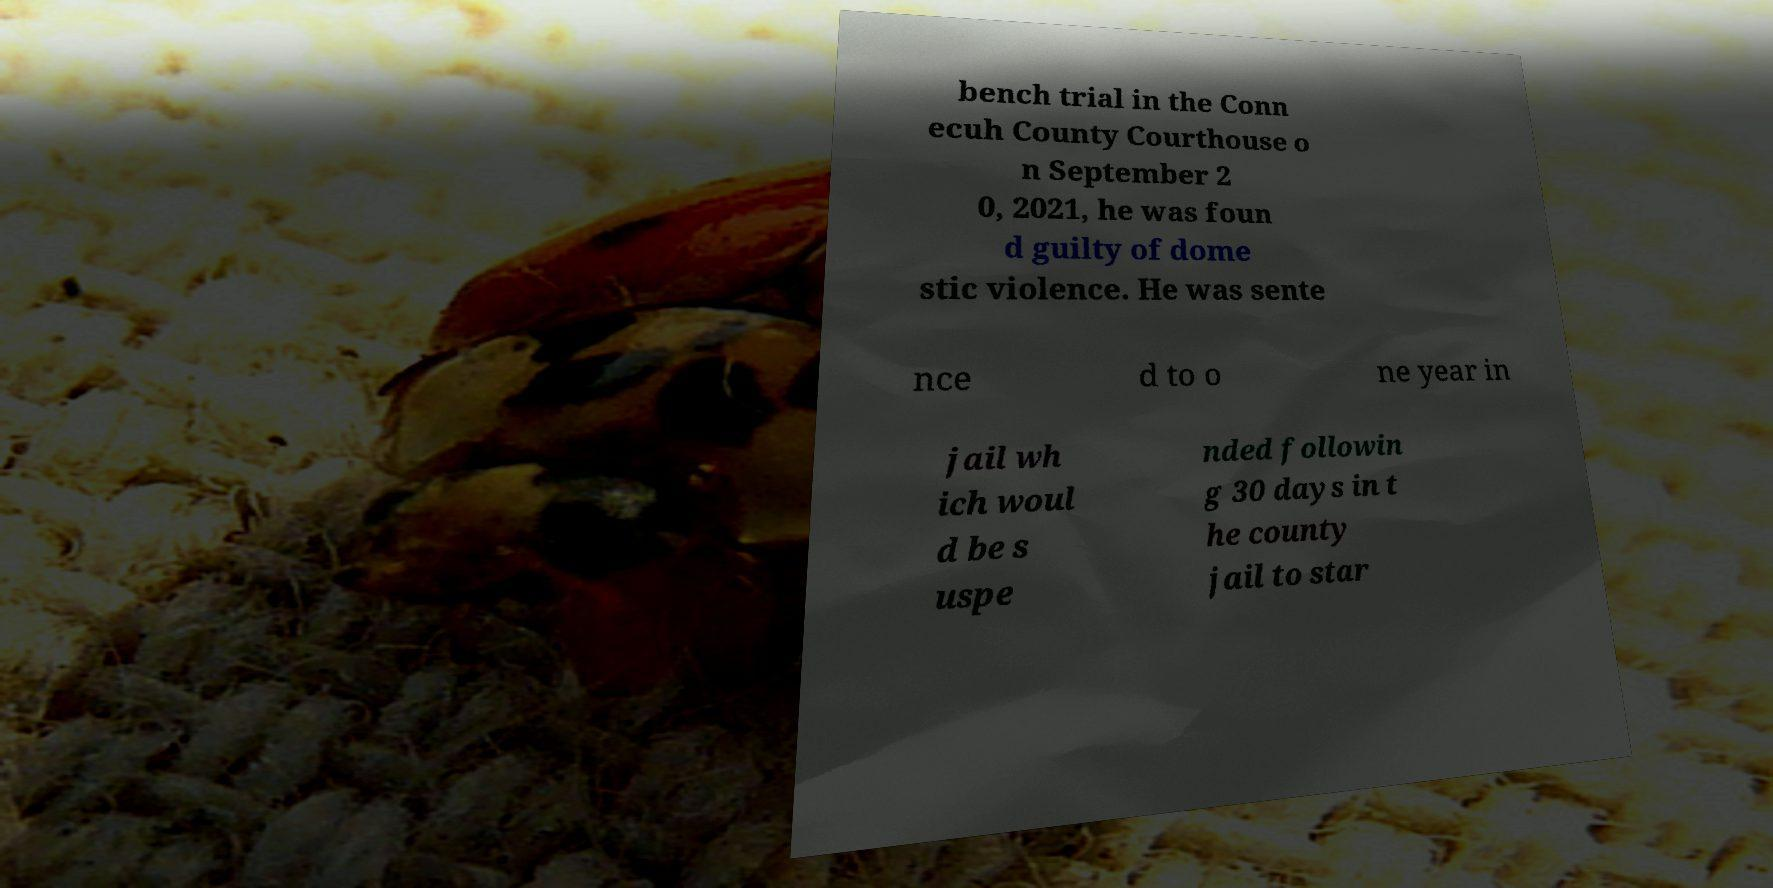There's text embedded in this image that I need extracted. Can you transcribe it verbatim? bench trial in the Conn ecuh County Courthouse o n September 2 0, 2021, he was foun d guilty of dome stic violence. He was sente nce d to o ne year in jail wh ich woul d be s uspe nded followin g 30 days in t he county jail to star 